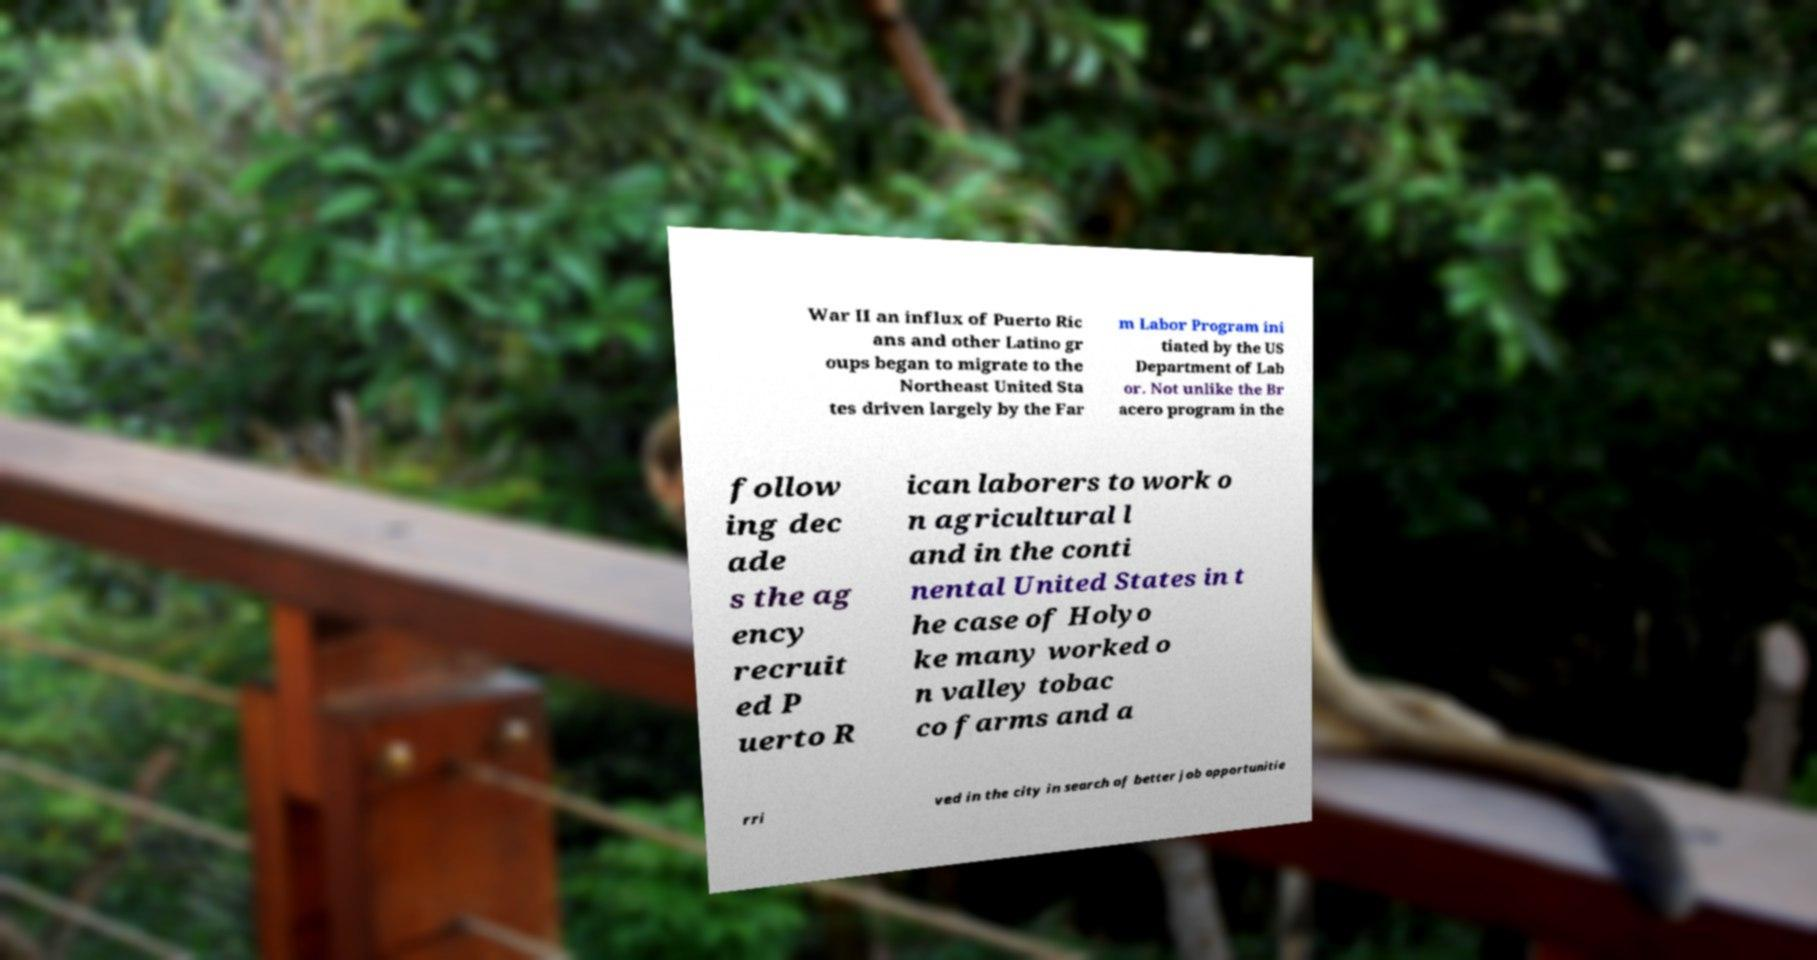For documentation purposes, I need the text within this image transcribed. Could you provide that? War II an influx of Puerto Ric ans and other Latino gr oups began to migrate to the Northeast United Sta tes driven largely by the Far m Labor Program ini tiated by the US Department of Lab or. Not unlike the Br acero program in the follow ing dec ade s the ag ency recruit ed P uerto R ican laborers to work o n agricultural l and in the conti nental United States in t he case of Holyo ke many worked o n valley tobac co farms and a rri ved in the city in search of better job opportunitie 